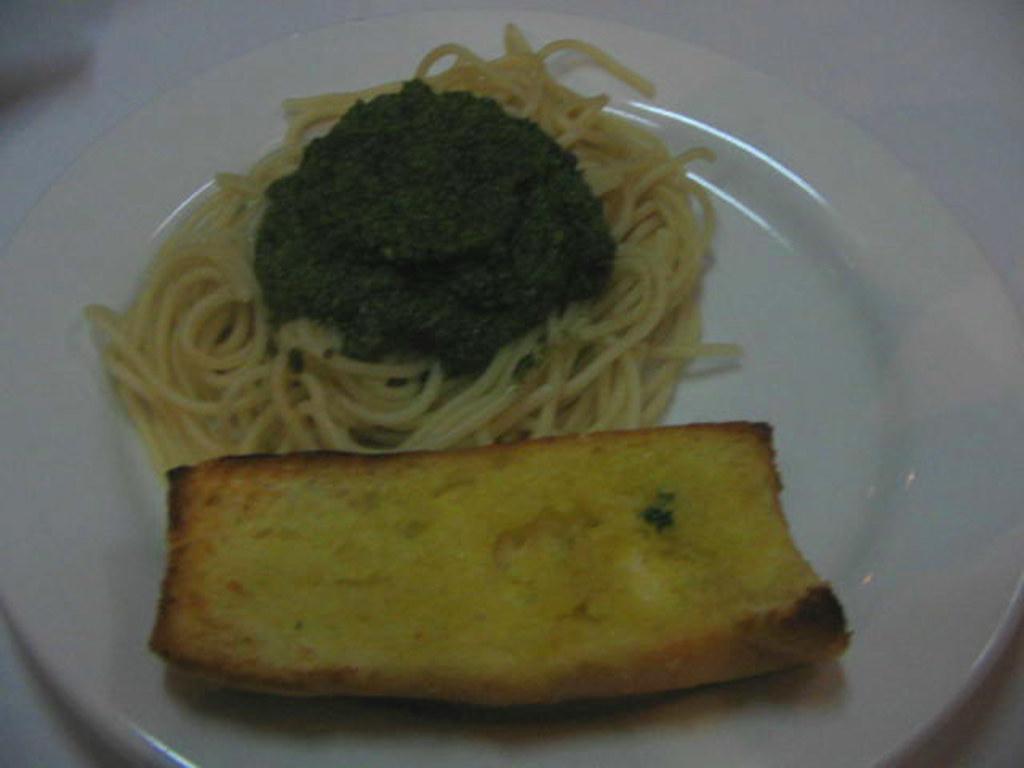Can you describe this image briefly? In this image we can see the food item in the plate and the plate placed on the surface which looks like a table. 